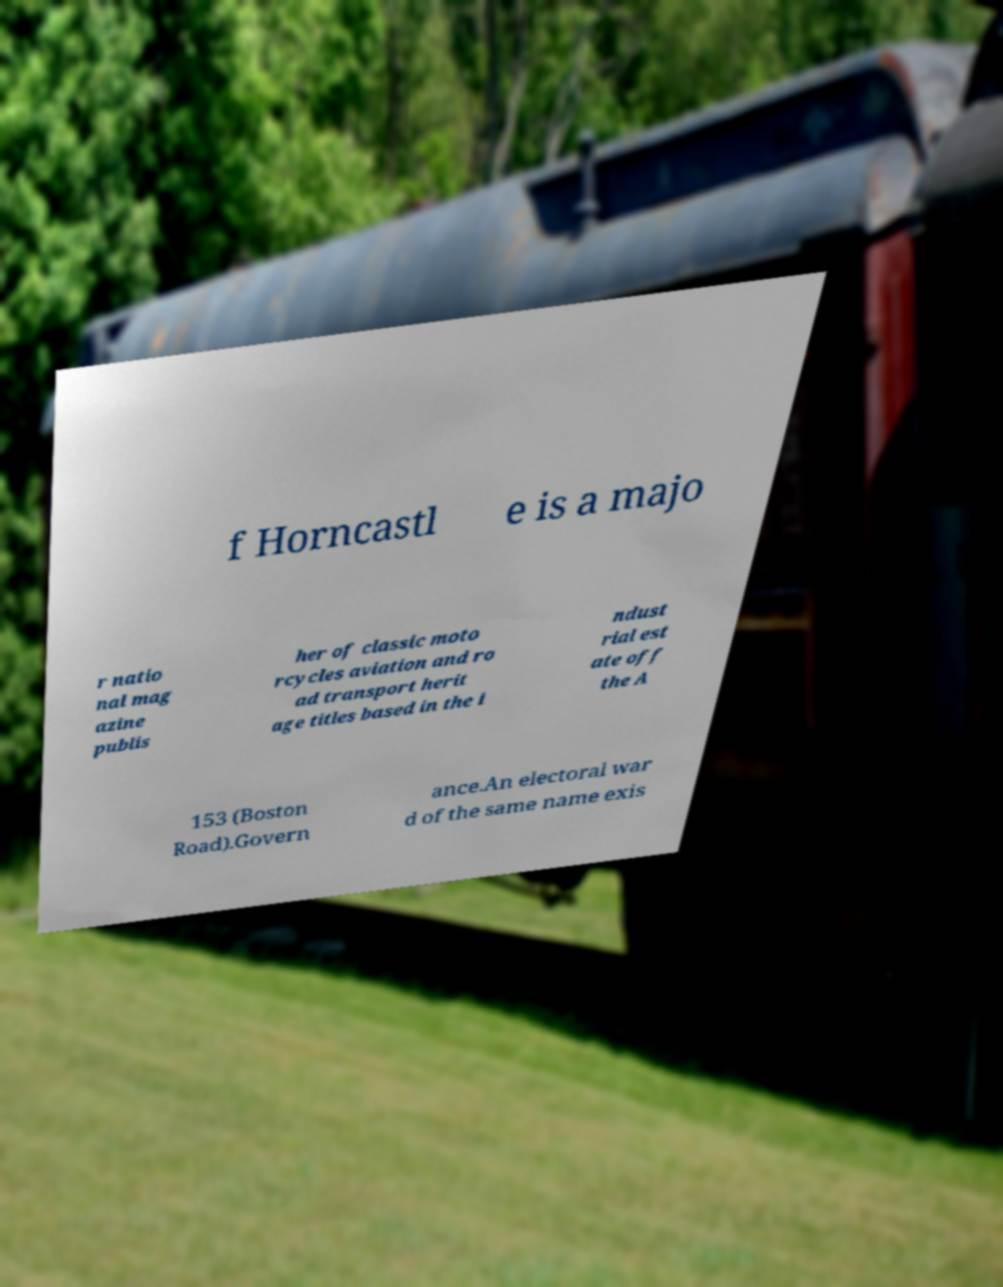Please read and relay the text visible in this image. What does it say? f Horncastl e is a majo r natio nal mag azine publis her of classic moto rcycles aviation and ro ad transport herit age titles based in the i ndust rial est ate off the A 153 (Boston Road).Govern ance.An electoral war d of the same name exis 